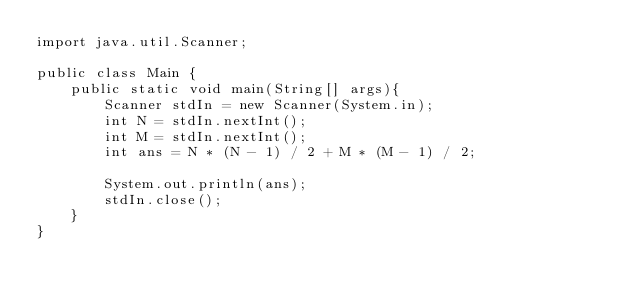<code> <loc_0><loc_0><loc_500><loc_500><_Java_>import java.util.Scanner;

public class Main {
	public static void main(String[] args){
		Scanner stdIn = new Scanner(System.in);
		int N = stdIn.nextInt();
		int M = stdIn.nextInt();
		int ans = N * (N - 1) / 2 + M * (M - 1) / 2;

		System.out.println(ans);
		stdIn.close();
	}
}
</code> 